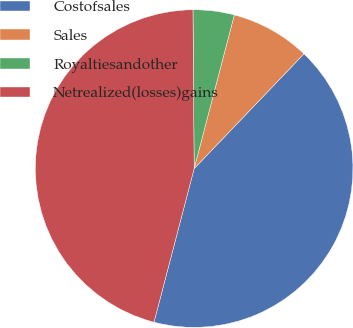Convert chart. <chart><loc_0><loc_0><loc_500><loc_500><pie_chart><fcel>Costofsales<fcel>Sales<fcel>Royaltiesandother<fcel>Netrealized(losses)gains<nl><fcel>41.92%<fcel>8.08%<fcel>4.19%<fcel>45.81%<nl></chart> 